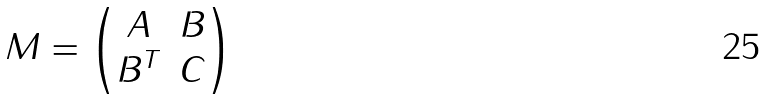<formula> <loc_0><loc_0><loc_500><loc_500>M = \begin{pmatrix} A & B \\ B ^ { T } & C \end{pmatrix}</formula> 